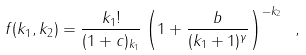Convert formula to latex. <formula><loc_0><loc_0><loc_500><loc_500>f ( k _ { 1 } , k _ { 2 } ) = \frac { k _ { 1 } ! } { ( 1 + c ) _ { k _ { 1 } } } \left ( 1 + \frac { b } { ( k _ { 1 } + 1 ) ^ { \gamma } } \right ) ^ { - k _ { 2 } } \ ,</formula> 